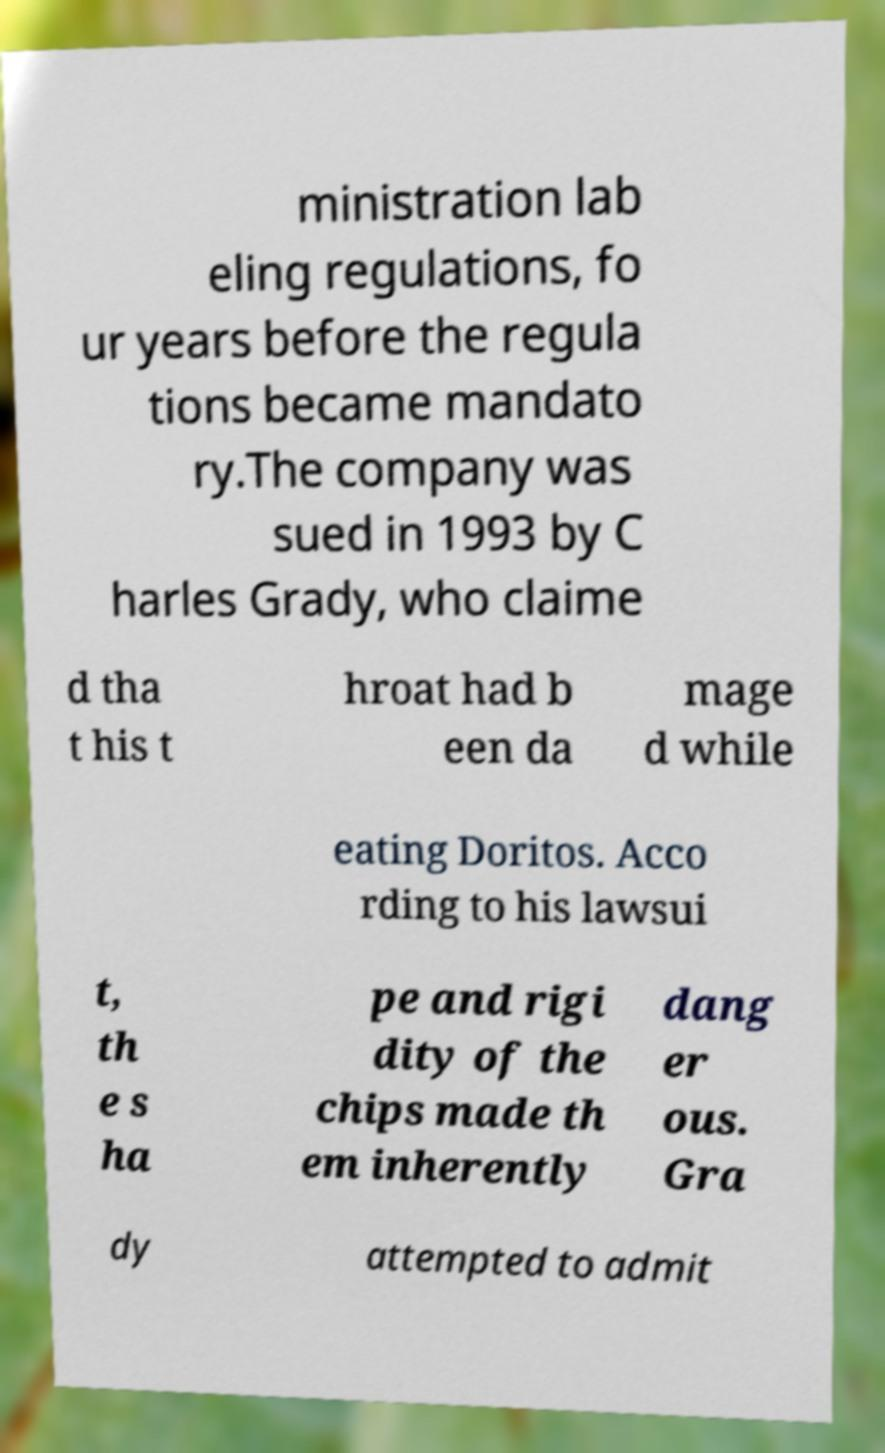Could you extract and type out the text from this image? ministration lab eling regulations, fo ur years before the regula tions became mandato ry.The company was sued in 1993 by C harles Grady, who claime d tha t his t hroat had b een da mage d while eating Doritos. Acco rding to his lawsui t, th e s ha pe and rigi dity of the chips made th em inherently dang er ous. Gra dy attempted to admit 